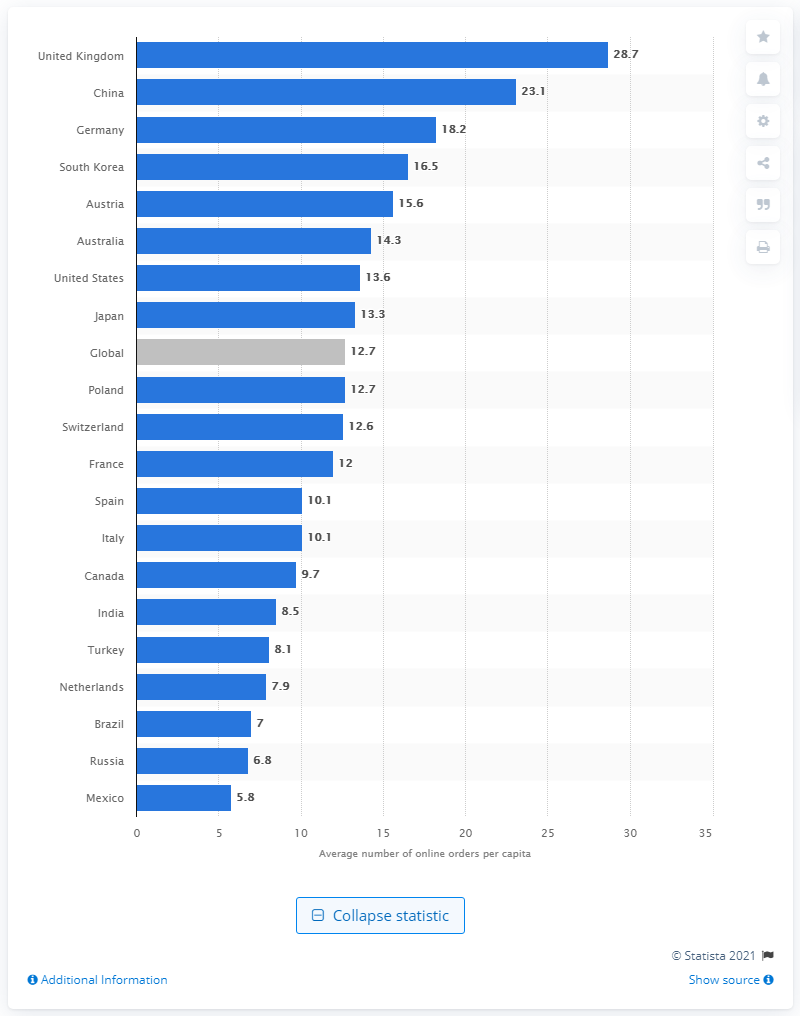List a handful of essential elements in this visual. The annual online orders per capita in the UK in 2013 was 28.7. 